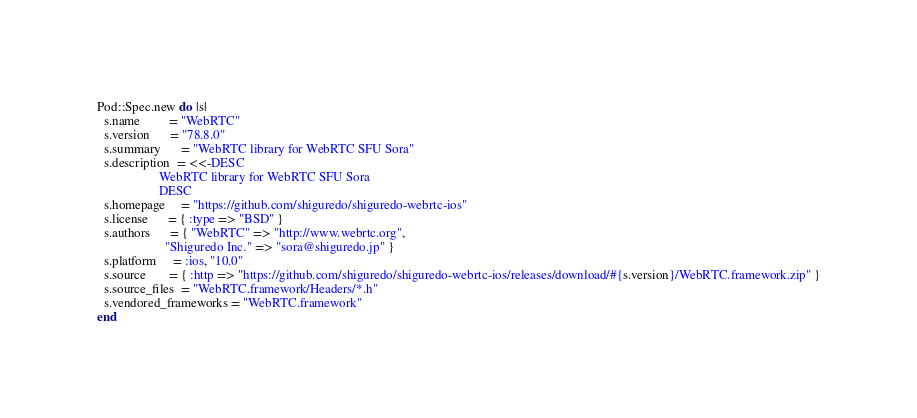Convert code to text. <code><loc_0><loc_0><loc_500><loc_500><_Ruby_>Pod::Spec.new do |s|
  s.name         = "WebRTC"
  s.version      = "78.8.0"
  s.summary      = "WebRTC library for WebRTC SFU Sora"
  s.description  = <<-DESC
                   WebRTC library for WebRTC SFU Sora
                   DESC
  s.homepage     = "https://github.com/shiguredo/shiguredo-webrtc-ios"
  s.license      = { :type => "BSD" }
  s.authors      = { "WebRTC" => "http://www.webrtc.org",
                     "Shiguredo Inc." => "sora@shiguredo.jp" }
  s.platform     = :ios, "10.0"
  s.source       = { :http => "https://github.com/shiguredo/shiguredo-webrtc-ios/releases/download/#{s.version}/WebRTC.framework.zip" }
  s.source_files  = "WebRTC.framework/Headers/*.h"
  s.vendored_frameworks = "WebRTC.framework"
end
</code> 